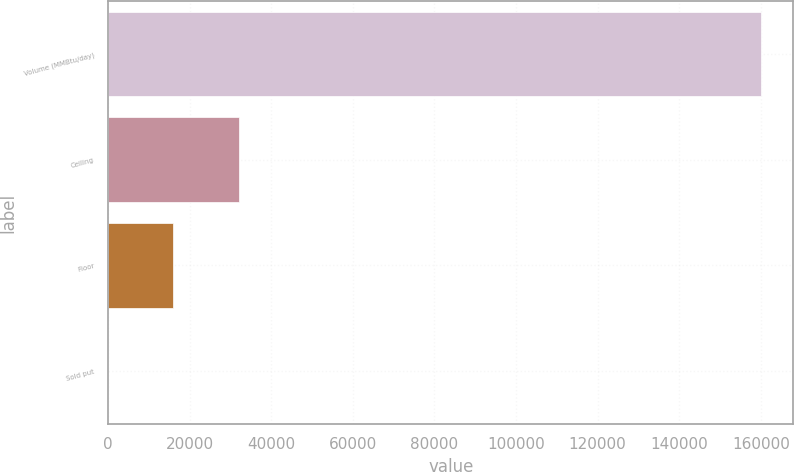<chart> <loc_0><loc_0><loc_500><loc_500><bar_chart><fcel>Volume (MMBtu/day)<fcel>Ceiling<fcel>Floor<fcel>Sold put<nl><fcel>160000<fcel>32002<fcel>16002.2<fcel>2.5<nl></chart> 